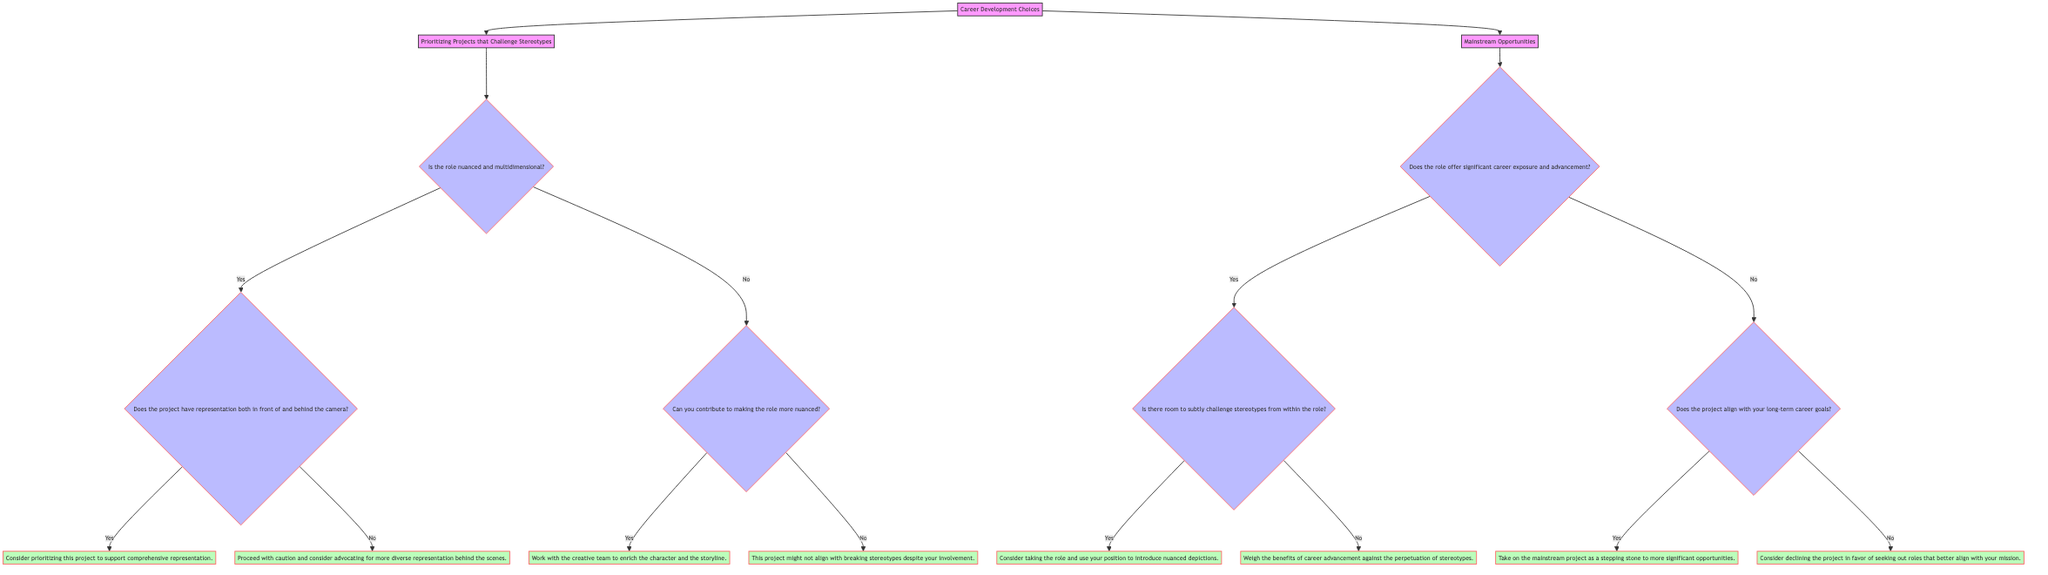What's the first decision point in the diagram? The first decision point is represented by the node that asks, "Is the role nuanced and multidimensional?" which falls under the "Prioritizing Projects that Challenge Stereotypes" section.
Answer: Is the role nuanced and multidimensional? How many main branches does the diagram have? The diagram has two main branches: "Prioritizing Projects that Challenge Stereotypes" and "Mainstream Opportunities."
Answer: 2 What action is suggested if the project has representation both in front of and behind the camera? If the project has representation both in front of and behind the camera, the action suggested is to "Consider prioritizing this project to support comprehensive representation."
Answer: Consider prioritizing this project to support comprehensive representation What happens if the role does not offer significant career exposure and advancement? If the role does not offer significant career exposure and advancement, the next question asked will be, "Does the project align with your long-term career goals?"
Answer: Does the project align with your long-term career goals? What is the suggested action if you can contribute to making the role more nuanced? If you can contribute to making the role more nuanced, the suggested action is to "Work with the creative team to enrich the character and the storyline."
Answer: Work with the creative team to enrich the character and the storyline What question follows if the role offers significant career exposure and advancement? If the role offers significant career exposure and advancement, the next question asked is "Is there room to subtly challenge stereotypes from within the role?"
Answer: Is there room to subtly challenge stereotypes from within the role? What is the action to take if the long-term career goals are not aligned with the project? The action to take would be to "Consider declining the project in favor of seeking out roles that better align with your mission."
Answer: Consider declining the project in favor of seeking out roles that better align with your mission If you cannot contribute to making the role more nuanced, what does the diagram suggest? If you cannot contribute to making the role more nuanced, the diagram suggests that "This project might not align with breaking stereotypes despite your involvement."
Answer: This project might not align with breaking stereotypes despite your involvement 